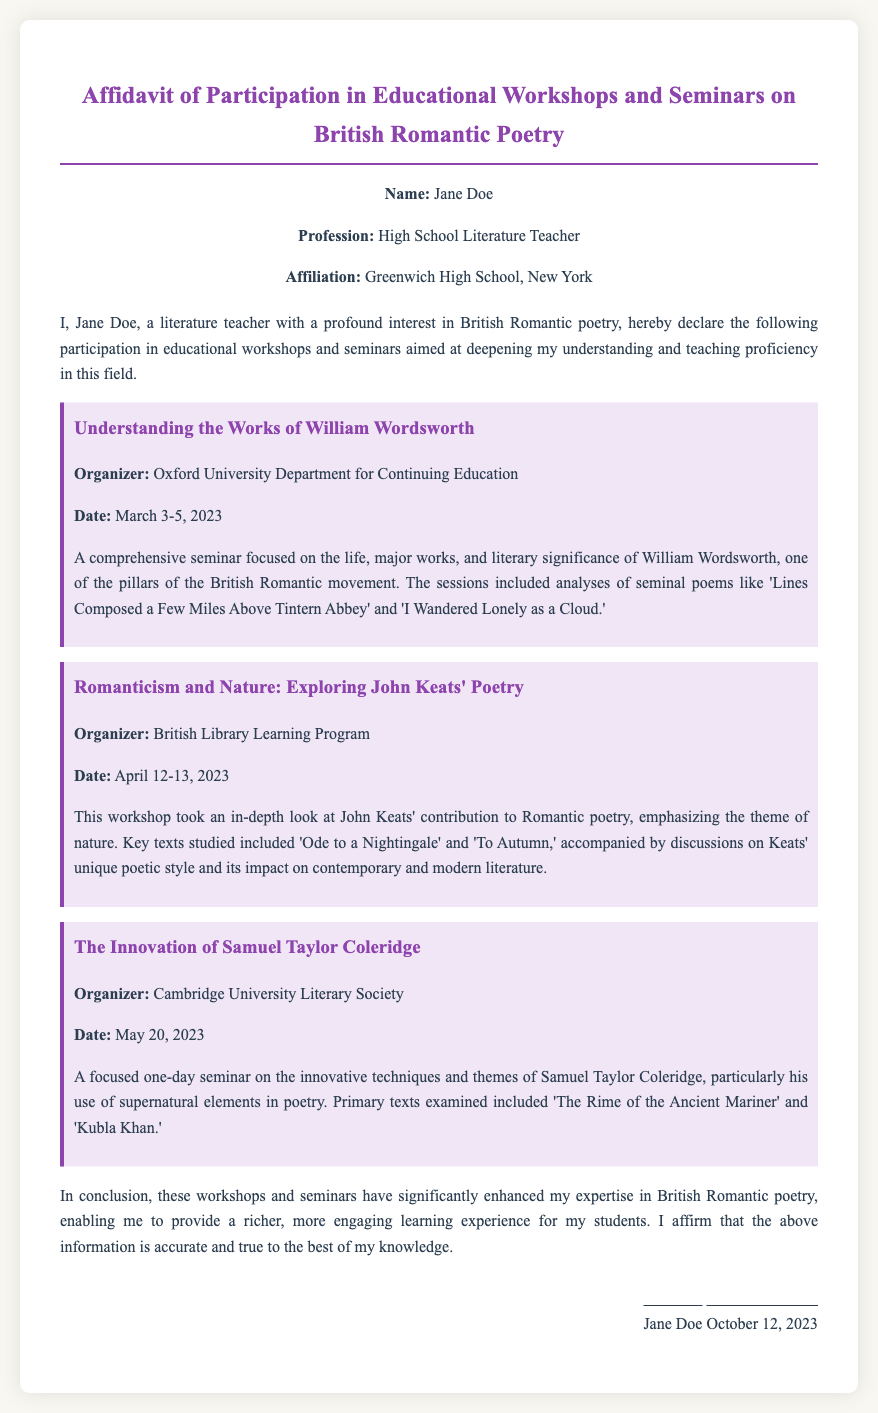What is the name of the person making the affidavit? The first paragraph of the document identifies the affiant as Jane Doe.
Answer: Jane Doe What is the profession of Jane Doe? The personal information section states that she is a high school literature teacher.
Answer: High School Literature Teacher On which dates was the workshop on William Wordsworth held? The details of the workshop specify the dates as March 3-5, 2023.
Answer: March 3-5, 2023 Which organization organized the seminar on John Keats? The document mentions that the British Library Learning Program organized this workshop.
Answer: British Library Learning Program What is one key poem discussed in the workshop on Samuel Taylor Coleridge? The document lists 'The Rime of the Ancient Mariner' as a primary text examined in the seminar.
Answer: The Rime of the Ancient Mariner How many workshops were attended by Jane Doe? The document lists three distinct workshops that Jane Doe participated in.
Answer: Three What is the conclusion drawn by Jane Doe about the workshops? In her conclusion, Jane Doe asserts that the workshops enhanced her expertise in British Romantic poetry.
Answer: Enhanced her expertise What is the date on which the affidavit was signed? The signature section of the document records the date as October 12, 2023.
Answer: October 12, 2023 What is the main theme of the workshop focusing on John Keats? The workshop on John Keats emphasized the theme of nature in his poetry.
Answer: Nature 